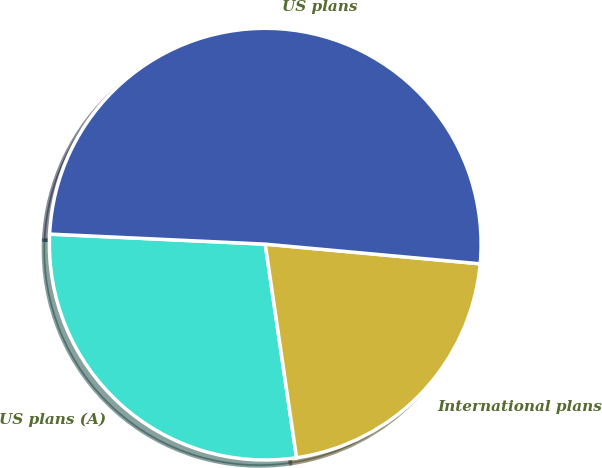Convert chart to OTSL. <chart><loc_0><loc_0><loc_500><loc_500><pie_chart><fcel>US plans (A)<fcel>International plans<fcel>US plans<nl><fcel>28.06%<fcel>21.23%<fcel>50.71%<nl></chart> 